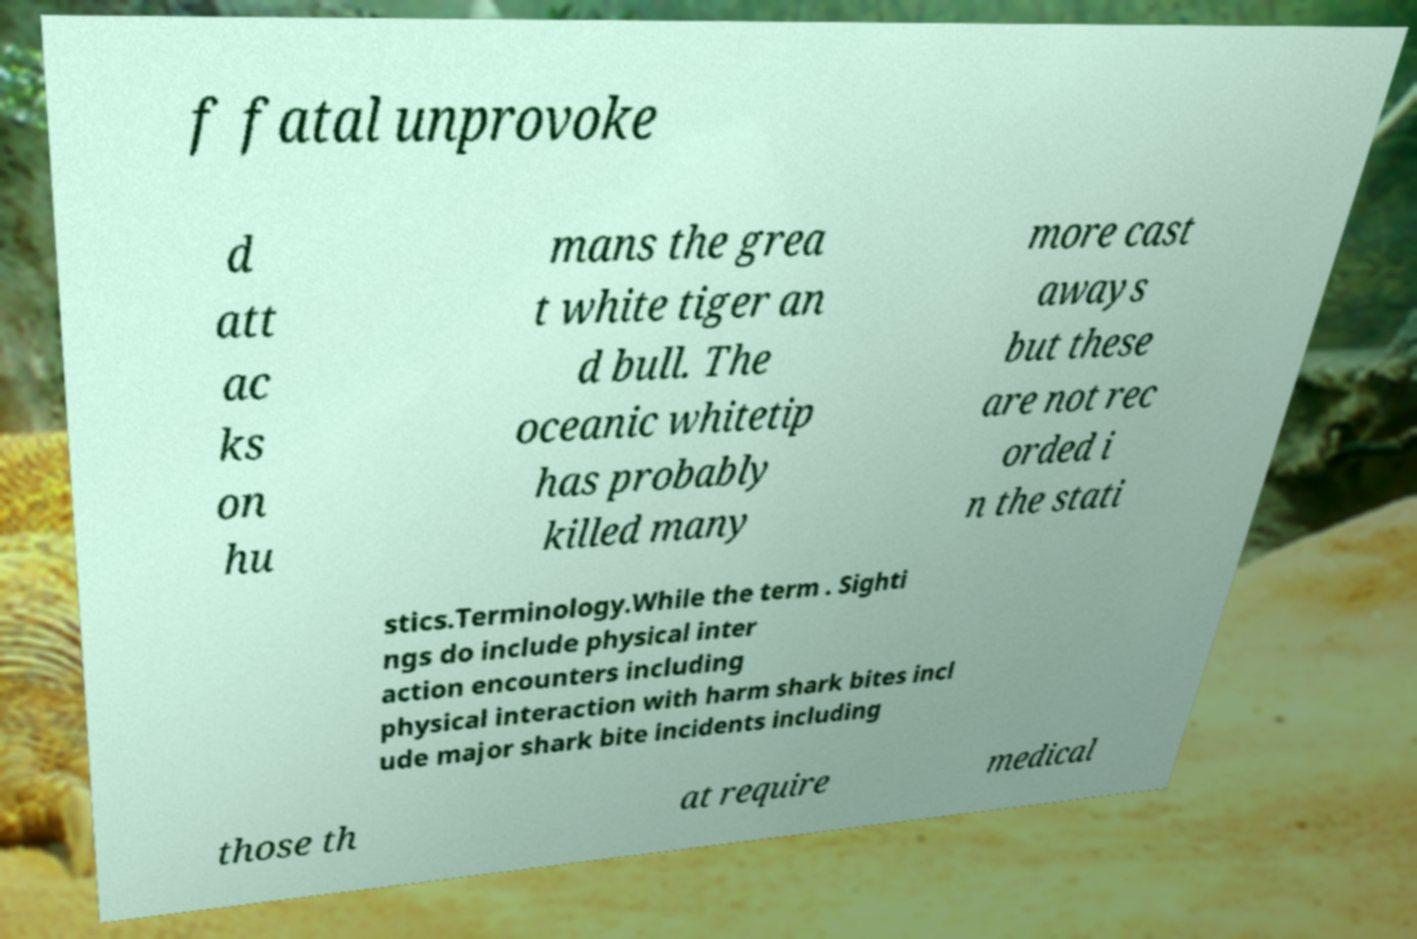Please read and relay the text visible in this image. What does it say? f fatal unprovoke d att ac ks on hu mans the grea t white tiger an d bull. The oceanic whitetip has probably killed many more cast aways but these are not rec orded i n the stati stics.Terminology.While the term . Sighti ngs do include physical inter action encounters including physical interaction with harm shark bites incl ude major shark bite incidents including those th at require medical 